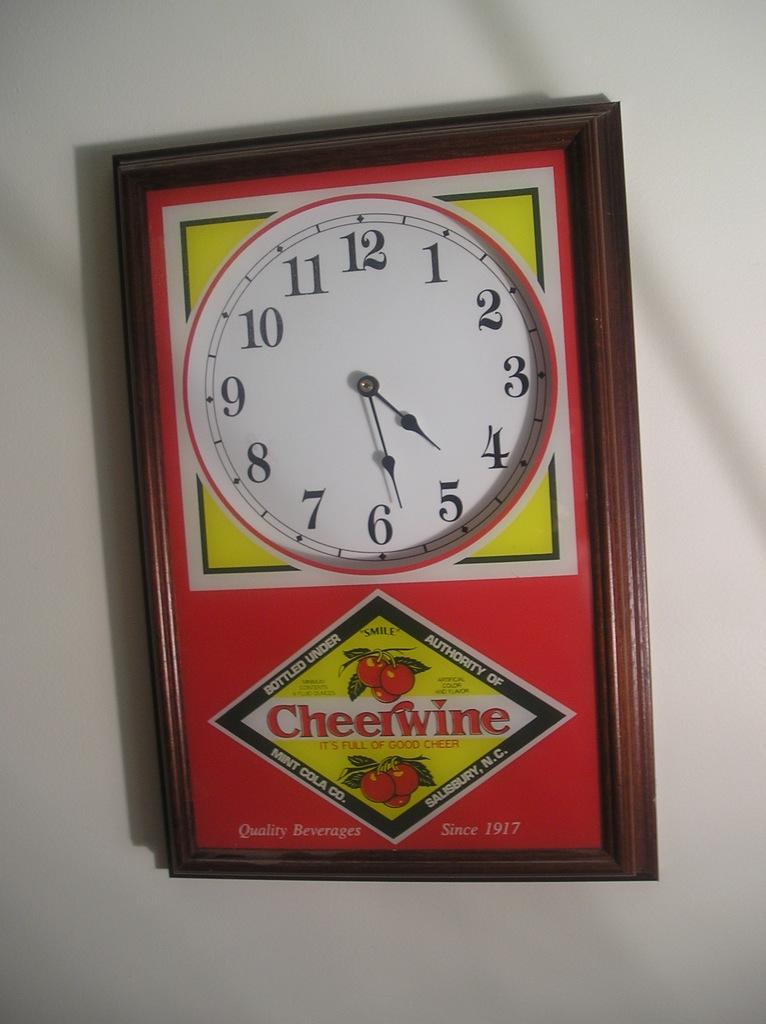What time is it ?
Keep it short and to the point. 4:28. What company is on the bottom of the clock?
Provide a short and direct response. Cheerwine. 